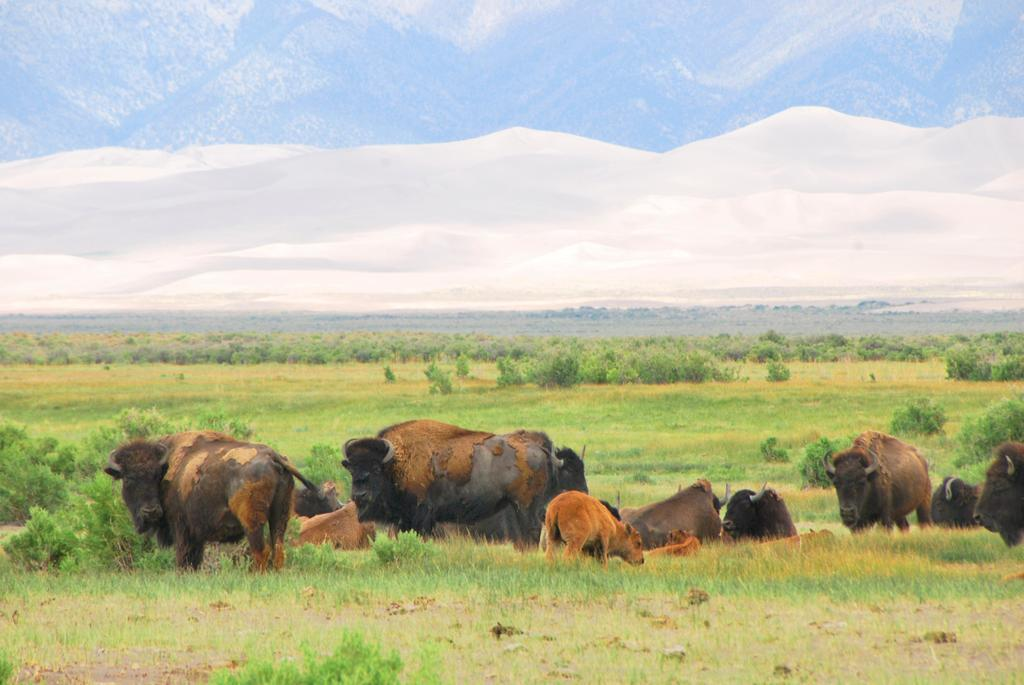What type of vegetation covers the land in the image? The land is covered with many plants and grass. What animals can be seen on the land? There are oxen on the land. What can be seen in the background of the image? There are trees and mountains in the background of the image. What type of brass coil can be seen in the image? There is no brass coil present in the image. 